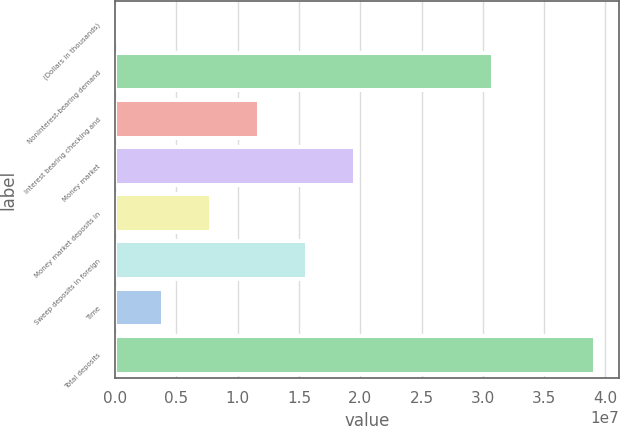Convert chart to OTSL. <chart><loc_0><loc_0><loc_500><loc_500><bar_chart><fcel>(Dollars in thousands)<fcel>Noninterest-bearing demand<fcel>Interest bearing checking and<fcel>Money market<fcel>Money market deposits in<fcel>Sweep deposits in foreign<fcel>Time<fcel>Total deposits<nl><fcel>2015<fcel>3.08675e+07<fcel>1.17442e+07<fcel>1.95724e+07<fcel>7.83017e+06<fcel>1.56583e+07<fcel>3.91609e+06<fcel>3.91428e+07<nl></chart> 